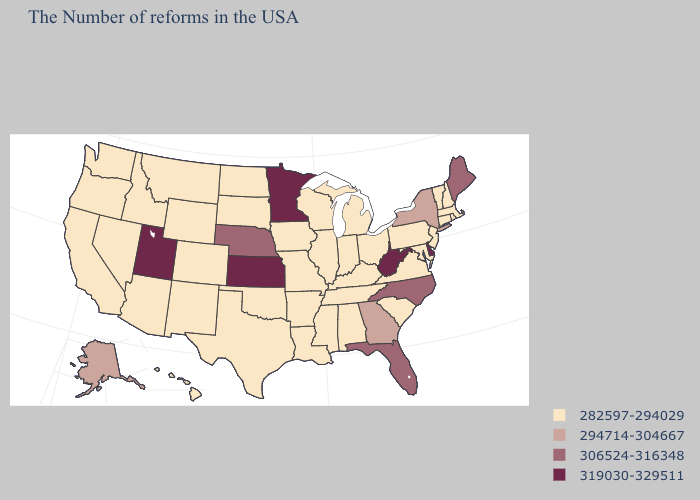Which states have the highest value in the USA?
Be succinct. Delaware, West Virginia, Minnesota, Kansas, Utah. Which states have the highest value in the USA?
Give a very brief answer. Delaware, West Virginia, Minnesota, Kansas, Utah. What is the highest value in the South ?
Answer briefly. 319030-329511. What is the value of Arkansas?
Quick response, please. 282597-294029. Does North Dakota have the highest value in the MidWest?
Concise answer only. No. What is the value of North Dakota?
Be succinct. 282597-294029. Name the states that have a value in the range 282597-294029?
Short answer required. Massachusetts, Rhode Island, New Hampshire, Vermont, Connecticut, New Jersey, Maryland, Pennsylvania, Virginia, South Carolina, Ohio, Michigan, Kentucky, Indiana, Alabama, Tennessee, Wisconsin, Illinois, Mississippi, Louisiana, Missouri, Arkansas, Iowa, Oklahoma, Texas, South Dakota, North Dakota, Wyoming, Colorado, New Mexico, Montana, Arizona, Idaho, Nevada, California, Washington, Oregon, Hawaii. Name the states that have a value in the range 282597-294029?
Short answer required. Massachusetts, Rhode Island, New Hampshire, Vermont, Connecticut, New Jersey, Maryland, Pennsylvania, Virginia, South Carolina, Ohio, Michigan, Kentucky, Indiana, Alabama, Tennessee, Wisconsin, Illinois, Mississippi, Louisiana, Missouri, Arkansas, Iowa, Oklahoma, Texas, South Dakota, North Dakota, Wyoming, Colorado, New Mexico, Montana, Arizona, Idaho, Nevada, California, Washington, Oregon, Hawaii. Among the states that border Kansas , which have the highest value?
Give a very brief answer. Nebraska. What is the lowest value in the Northeast?
Keep it brief. 282597-294029. Name the states that have a value in the range 282597-294029?
Give a very brief answer. Massachusetts, Rhode Island, New Hampshire, Vermont, Connecticut, New Jersey, Maryland, Pennsylvania, Virginia, South Carolina, Ohio, Michigan, Kentucky, Indiana, Alabama, Tennessee, Wisconsin, Illinois, Mississippi, Louisiana, Missouri, Arkansas, Iowa, Oklahoma, Texas, South Dakota, North Dakota, Wyoming, Colorado, New Mexico, Montana, Arizona, Idaho, Nevada, California, Washington, Oregon, Hawaii. What is the value of New Hampshire?
Write a very short answer. 282597-294029. What is the lowest value in the Northeast?
Give a very brief answer. 282597-294029. What is the value of Wisconsin?
Answer briefly. 282597-294029. Which states hav the highest value in the West?
Answer briefly. Utah. 